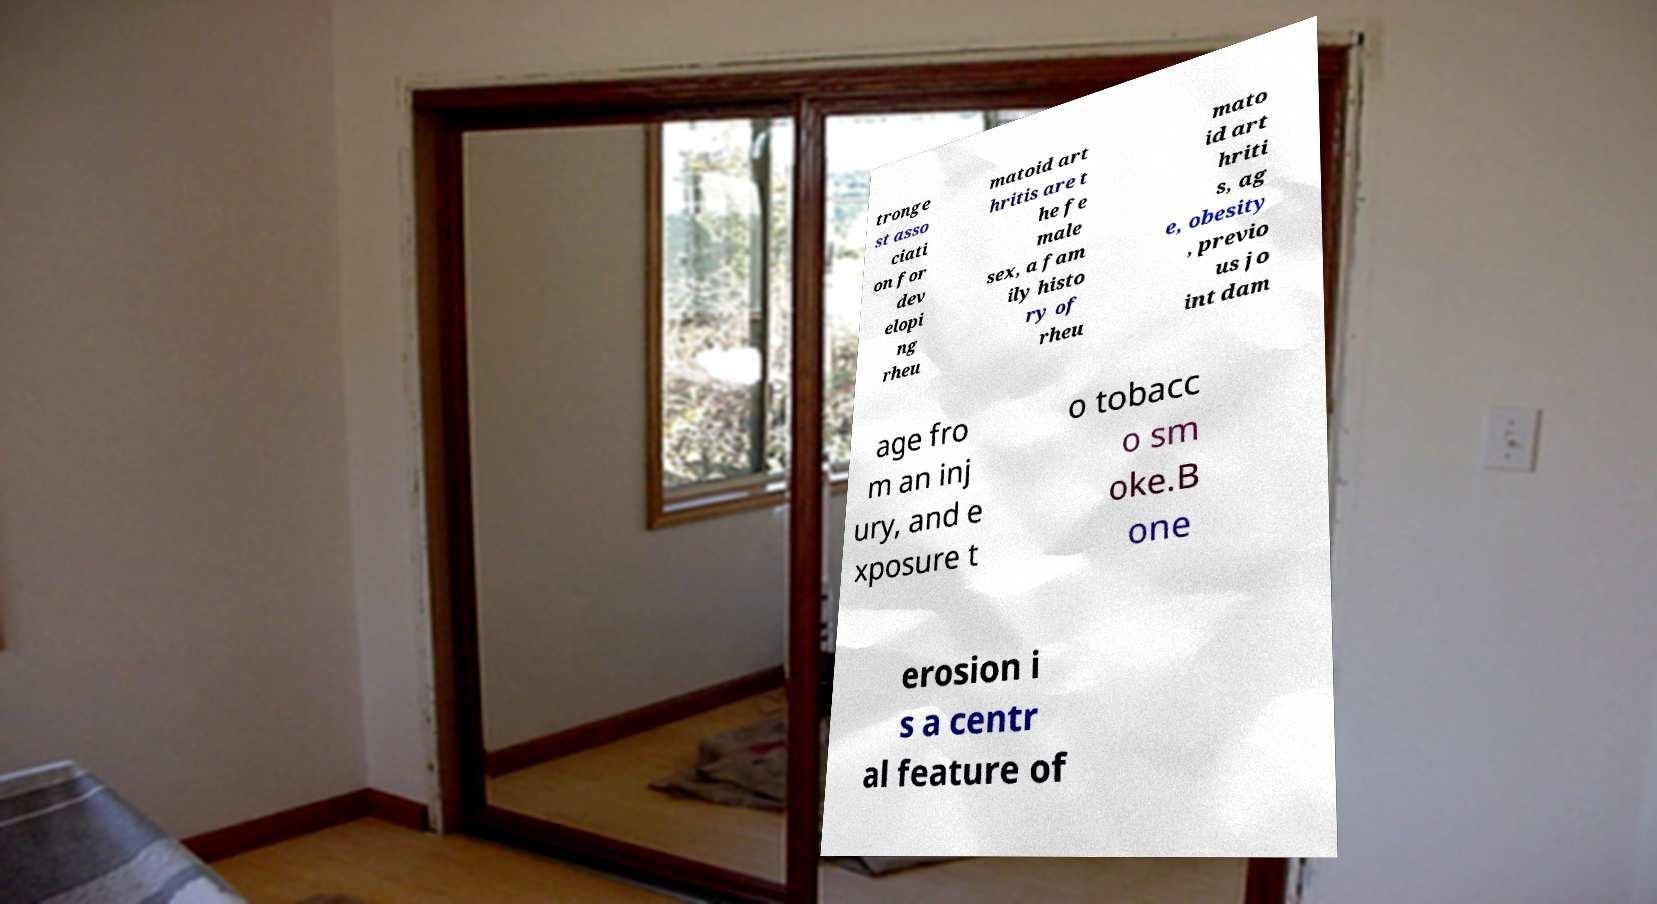Can you accurately transcribe the text from the provided image for me? tronge st asso ciati on for dev elopi ng rheu matoid art hritis are t he fe male sex, a fam ily histo ry of rheu mato id art hriti s, ag e, obesity , previo us jo int dam age fro m an inj ury, and e xposure t o tobacc o sm oke.B one erosion i s a centr al feature of 